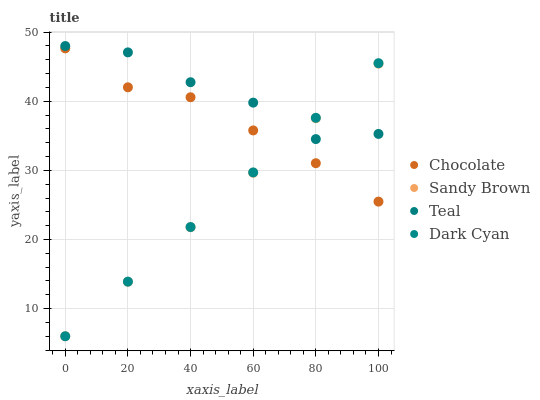Does Sandy Brown have the minimum area under the curve?
Answer yes or no. Yes. Does Teal have the maximum area under the curve?
Answer yes or no. Yes. Does Teal have the minimum area under the curve?
Answer yes or no. No. Does Sandy Brown have the maximum area under the curve?
Answer yes or no. No. Is Sandy Brown the smoothest?
Answer yes or no. Yes. Is Teal the roughest?
Answer yes or no. Yes. Is Teal the smoothest?
Answer yes or no. No. Is Sandy Brown the roughest?
Answer yes or no. No. Does Dark Cyan have the lowest value?
Answer yes or no. Yes. Does Teal have the lowest value?
Answer yes or no. No. Does Teal have the highest value?
Answer yes or no. Yes. Does Sandy Brown have the highest value?
Answer yes or no. No. Is Chocolate less than Teal?
Answer yes or no. Yes. Is Teal greater than Chocolate?
Answer yes or no. Yes. Does Chocolate intersect Dark Cyan?
Answer yes or no. Yes. Is Chocolate less than Dark Cyan?
Answer yes or no. No. Is Chocolate greater than Dark Cyan?
Answer yes or no. No. Does Chocolate intersect Teal?
Answer yes or no. No. 